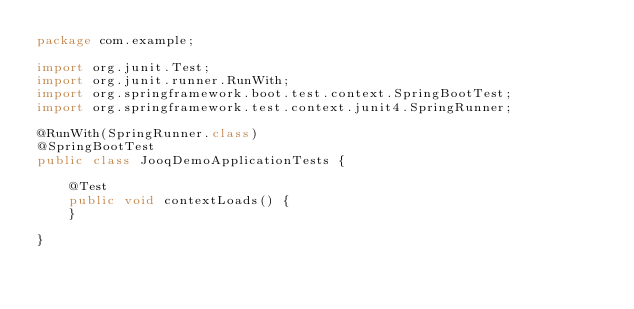Convert code to text. <code><loc_0><loc_0><loc_500><loc_500><_Java_>package com.example;

import org.junit.Test;
import org.junit.runner.RunWith;
import org.springframework.boot.test.context.SpringBootTest;
import org.springframework.test.context.junit4.SpringRunner;

@RunWith(SpringRunner.class)
@SpringBootTest
public class JooqDemoApplicationTests {

	@Test
	public void contextLoads() {
	}

}
</code> 